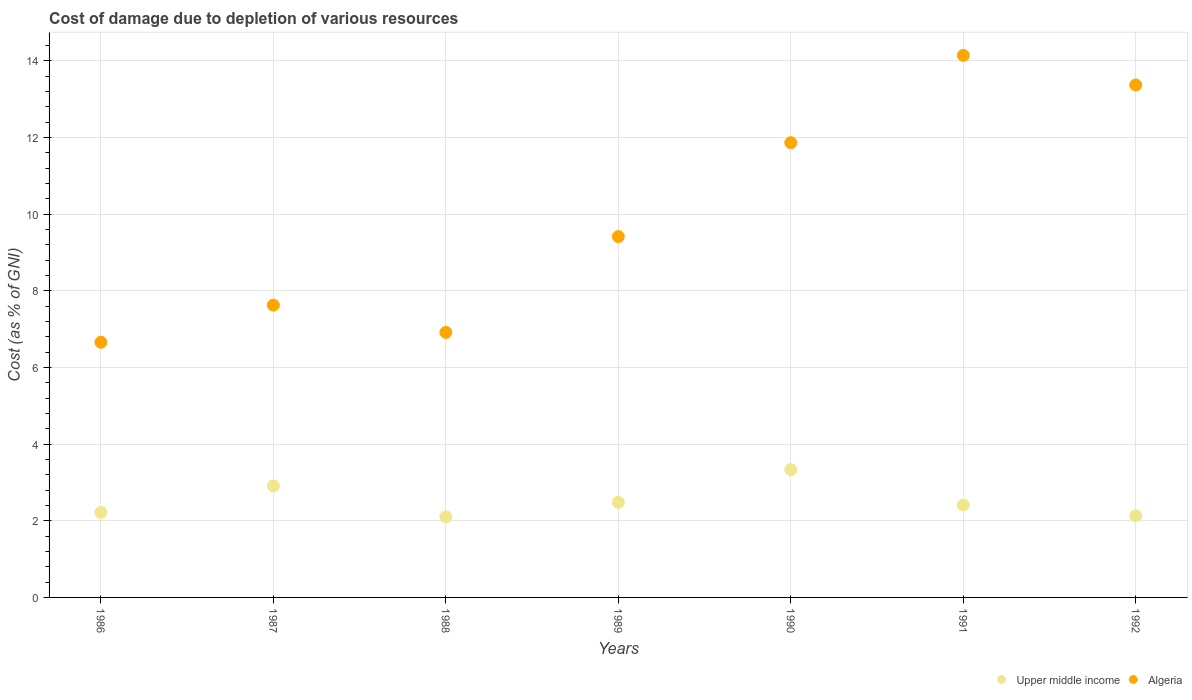What is the cost of damage caused due to the depletion of various resources in Upper middle income in 1989?
Ensure brevity in your answer.  2.48. Across all years, what is the maximum cost of damage caused due to the depletion of various resources in Algeria?
Keep it short and to the point. 14.15. Across all years, what is the minimum cost of damage caused due to the depletion of various resources in Algeria?
Provide a succinct answer. 6.66. In which year was the cost of damage caused due to the depletion of various resources in Algeria minimum?
Keep it short and to the point. 1986. What is the total cost of damage caused due to the depletion of various resources in Upper middle income in the graph?
Your answer should be very brief. 17.59. What is the difference between the cost of damage caused due to the depletion of various resources in Upper middle income in 1988 and that in 1991?
Your answer should be very brief. -0.31. What is the difference between the cost of damage caused due to the depletion of various resources in Upper middle income in 1990 and the cost of damage caused due to the depletion of various resources in Algeria in 1987?
Ensure brevity in your answer.  -4.29. What is the average cost of damage caused due to the depletion of various resources in Algeria per year?
Keep it short and to the point. 10. In the year 1987, what is the difference between the cost of damage caused due to the depletion of various resources in Algeria and cost of damage caused due to the depletion of various resources in Upper middle income?
Provide a succinct answer. 4.72. What is the ratio of the cost of damage caused due to the depletion of various resources in Algeria in 1989 to that in 1992?
Ensure brevity in your answer.  0.7. Is the cost of damage caused due to the depletion of various resources in Algeria in 1987 less than that in 1988?
Ensure brevity in your answer.  No. Is the difference between the cost of damage caused due to the depletion of various resources in Algeria in 1987 and 1990 greater than the difference between the cost of damage caused due to the depletion of various resources in Upper middle income in 1987 and 1990?
Offer a very short reply. No. What is the difference between the highest and the second highest cost of damage caused due to the depletion of various resources in Upper middle income?
Offer a very short reply. 0.42. What is the difference between the highest and the lowest cost of damage caused due to the depletion of various resources in Algeria?
Your answer should be very brief. 7.49. In how many years, is the cost of damage caused due to the depletion of various resources in Algeria greater than the average cost of damage caused due to the depletion of various resources in Algeria taken over all years?
Your response must be concise. 3. Is the cost of damage caused due to the depletion of various resources in Upper middle income strictly greater than the cost of damage caused due to the depletion of various resources in Algeria over the years?
Provide a succinct answer. No. Is the cost of damage caused due to the depletion of various resources in Upper middle income strictly less than the cost of damage caused due to the depletion of various resources in Algeria over the years?
Provide a succinct answer. Yes. How many years are there in the graph?
Your response must be concise. 7. Does the graph contain any zero values?
Ensure brevity in your answer.  No. Where does the legend appear in the graph?
Make the answer very short. Bottom right. How many legend labels are there?
Offer a very short reply. 2. How are the legend labels stacked?
Keep it short and to the point. Horizontal. What is the title of the graph?
Provide a short and direct response. Cost of damage due to depletion of various resources. Does "Kiribati" appear as one of the legend labels in the graph?
Offer a terse response. No. What is the label or title of the Y-axis?
Ensure brevity in your answer.  Cost (as % of GNI). What is the Cost (as % of GNI) in Upper middle income in 1986?
Provide a short and direct response. 2.22. What is the Cost (as % of GNI) in Algeria in 1986?
Provide a succinct answer. 6.66. What is the Cost (as % of GNI) of Upper middle income in 1987?
Keep it short and to the point. 2.91. What is the Cost (as % of GNI) in Algeria in 1987?
Provide a succinct answer. 7.63. What is the Cost (as % of GNI) of Upper middle income in 1988?
Give a very brief answer. 2.1. What is the Cost (as % of GNI) in Algeria in 1988?
Offer a very short reply. 6.92. What is the Cost (as % of GNI) of Upper middle income in 1989?
Provide a short and direct response. 2.48. What is the Cost (as % of GNI) in Algeria in 1989?
Your answer should be very brief. 9.42. What is the Cost (as % of GNI) of Upper middle income in 1990?
Provide a succinct answer. 3.33. What is the Cost (as % of GNI) of Algeria in 1990?
Give a very brief answer. 11.87. What is the Cost (as % of GNI) of Upper middle income in 1991?
Your answer should be compact. 2.41. What is the Cost (as % of GNI) in Algeria in 1991?
Provide a short and direct response. 14.15. What is the Cost (as % of GNI) in Upper middle income in 1992?
Provide a succinct answer. 2.13. What is the Cost (as % of GNI) in Algeria in 1992?
Make the answer very short. 13.37. Across all years, what is the maximum Cost (as % of GNI) in Upper middle income?
Offer a terse response. 3.33. Across all years, what is the maximum Cost (as % of GNI) of Algeria?
Your answer should be compact. 14.15. Across all years, what is the minimum Cost (as % of GNI) of Upper middle income?
Your answer should be very brief. 2.1. Across all years, what is the minimum Cost (as % of GNI) of Algeria?
Provide a succinct answer. 6.66. What is the total Cost (as % of GNI) of Upper middle income in the graph?
Your answer should be very brief. 17.59. What is the total Cost (as % of GNI) of Algeria in the graph?
Make the answer very short. 70.01. What is the difference between the Cost (as % of GNI) of Upper middle income in 1986 and that in 1987?
Offer a very short reply. -0.69. What is the difference between the Cost (as % of GNI) in Algeria in 1986 and that in 1987?
Your response must be concise. -0.97. What is the difference between the Cost (as % of GNI) in Upper middle income in 1986 and that in 1988?
Ensure brevity in your answer.  0.12. What is the difference between the Cost (as % of GNI) of Algeria in 1986 and that in 1988?
Ensure brevity in your answer.  -0.26. What is the difference between the Cost (as % of GNI) in Upper middle income in 1986 and that in 1989?
Provide a succinct answer. -0.26. What is the difference between the Cost (as % of GNI) in Algeria in 1986 and that in 1989?
Provide a succinct answer. -2.76. What is the difference between the Cost (as % of GNI) of Upper middle income in 1986 and that in 1990?
Ensure brevity in your answer.  -1.12. What is the difference between the Cost (as % of GNI) in Algeria in 1986 and that in 1990?
Your answer should be compact. -5.21. What is the difference between the Cost (as % of GNI) in Upper middle income in 1986 and that in 1991?
Your answer should be very brief. -0.19. What is the difference between the Cost (as % of GNI) in Algeria in 1986 and that in 1991?
Your response must be concise. -7.49. What is the difference between the Cost (as % of GNI) in Upper middle income in 1986 and that in 1992?
Offer a terse response. 0.09. What is the difference between the Cost (as % of GNI) in Algeria in 1986 and that in 1992?
Offer a very short reply. -6.71. What is the difference between the Cost (as % of GNI) of Upper middle income in 1987 and that in 1988?
Provide a short and direct response. 0.81. What is the difference between the Cost (as % of GNI) in Algeria in 1987 and that in 1988?
Your answer should be compact. 0.71. What is the difference between the Cost (as % of GNI) of Upper middle income in 1987 and that in 1989?
Provide a short and direct response. 0.43. What is the difference between the Cost (as % of GNI) in Algeria in 1987 and that in 1989?
Offer a terse response. -1.79. What is the difference between the Cost (as % of GNI) in Upper middle income in 1987 and that in 1990?
Offer a terse response. -0.42. What is the difference between the Cost (as % of GNI) of Algeria in 1987 and that in 1990?
Your answer should be compact. -4.24. What is the difference between the Cost (as % of GNI) of Upper middle income in 1987 and that in 1991?
Provide a succinct answer. 0.5. What is the difference between the Cost (as % of GNI) of Algeria in 1987 and that in 1991?
Ensure brevity in your answer.  -6.52. What is the difference between the Cost (as % of GNI) in Upper middle income in 1987 and that in 1992?
Keep it short and to the point. 0.78. What is the difference between the Cost (as % of GNI) in Algeria in 1987 and that in 1992?
Your answer should be very brief. -5.75. What is the difference between the Cost (as % of GNI) in Upper middle income in 1988 and that in 1989?
Ensure brevity in your answer.  -0.38. What is the difference between the Cost (as % of GNI) of Algeria in 1988 and that in 1989?
Offer a very short reply. -2.5. What is the difference between the Cost (as % of GNI) in Upper middle income in 1988 and that in 1990?
Give a very brief answer. -1.23. What is the difference between the Cost (as % of GNI) of Algeria in 1988 and that in 1990?
Keep it short and to the point. -4.95. What is the difference between the Cost (as % of GNI) of Upper middle income in 1988 and that in 1991?
Make the answer very short. -0.31. What is the difference between the Cost (as % of GNI) in Algeria in 1988 and that in 1991?
Offer a terse response. -7.23. What is the difference between the Cost (as % of GNI) in Upper middle income in 1988 and that in 1992?
Give a very brief answer. -0.03. What is the difference between the Cost (as % of GNI) of Algeria in 1988 and that in 1992?
Your answer should be very brief. -6.46. What is the difference between the Cost (as % of GNI) in Upper middle income in 1989 and that in 1990?
Ensure brevity in your answer.  -0.85. What is the difference between the Cost (as % of GNI) in Algeria in 1989 and that in 1990?
Offer a very short reply. -2.45. What is the difference between the Cost (as % of GNI) in Upper middle income in 1989 and that in 1991?
Offer a terse response. 0.07. What is the difference between the Cost (as % of GNI) in Algeria in 1989 and that in 1991?
Ensure brevity in your answer.  -4.73. What is the difference between the Cost (as % of GNI) in Upper middle income in 1989 and that in 1992?
Keep it short and to the point. 0.35. What is the difference between the Cost (as % of GNI) in Algeria in 1989 and that in 1992?
Offer a very short reply. -3.96. What is the difference between the Cost (as % of GNI) in Upper middle income in 1990 and that in 1991?
Ensure brevity in your answer.  0.92. What is the difference between the Cost (as % of GNI) of Algeria in 1990 and that in 1991?
Your response must be concise. -2.28. What is the difference between the Cost (as % of GNI) of Upper middle income in 1990 and that in 1992?
Offer a terse response. 1.2. What is the difference between the Cost (as % of GNI) of Algeria in 1990 and that in 1992?
Offer a terse response. -1.51. What is the difference between the Cost (as % of GNI) in Upper middle income in 1991 and that in 1992?
Offer a terse response. 0.28. What is the difference between the Cost (as % of GNI) of Algeria in 1991 and that in 1992?
Your response must be concise. 0.77. What is the difference between the Cost (as % of GNI) in Upper middle income in 1986 and the Cost (as % of GNI) in Algeria in 1987?
Keep it short and to the point. -5.41. What is the difference between the Cost (as % of GNI) of Upper middle income in 1986 and the Cost (as % of GNI) of Algeria in 1988?
Your answer should be very brief. -4.7. What is the difference between the Cost (as % of GNI) of Upper middle income in 1986 and the Cost (as % of GNI) of Algeria in 1989?
Give a very brief answer. -7.2. What is the difference between the Cost (as % of GNI) of Upper middle income in 1986 and the Cost (as % of GNI) of Algeria in 1990?
Provide a succinct answer. -9.65. What is the difference between the Cost (as % of GNI) of Upper middle income in 1986 and the Cost (as % of GNI) of Algeria in 1991?
Offer a terse response. -11.93. What is the difference between the Cost (as % of GNI) of Upper middle income in 1986 and the Cost (as % of GNI) of Algeria in 1992?
Provide a short and direct response. -11.16. What is the difference between the Cost (as % of GNI) in Upper middle income in 1987 and the Cost (as % of GNI) in Algeria in 1988?
Give a very brief answer. -4.01. What is the difference between the Cost (as % of GNI) of Upper middle income in 1987 and the Cost (as % of GNI) of Algeria in 1989?
Your response must be concise. -6.51. What is the difference between the Cost (as % of GNI) in Upper middle income in 1987 and the Cost (as % of GNI) in Algeria in 1990?
Provide a short and direct response. -8.96. What is the difference between the Cost (as % of GNI) in Upper middle income in 1987 and the Cost (as % of GNI) in Algeria in 1991?
Make the answer very short. -11.24. What is the difference between the Cost (as % of GNI) of Upper middle income in 1987 and the Cost (as % of GNI) of Algeria in 1992?
Your response must be concise. -10.46. What is the difference between the Cost (as % of GNI) in Upper middle income in 1988 and the Cost (as % of GNI) in Algeria in 1989?
Provide a short and direct response. -7.31. What is the difference between the Cost (as % of GNI) of Upper middle income in 1988 and the Cost (as % of GNI) of Algeria in 1990?
Your response must be concise. -9.77. What is the difference between the Cost (as % of GNI) of Upper middle income in 1988 and the Cost (as % of GNI) of Algeria in 1991?
Your answer should be compact. -12.04. What is the difference between the Cost (as % of GNI) in Upper middle income in 1988 and the Cost (as % of GNI) in Algeria in 1992?
Make the answer very short. -11.27. What is the difference between the Cost (as % of GNI) in Upper middle income in 1989 and the Cost (as % of GNI) in Algeria in 1990?
Provide a short and direct response. -9.39. What is the difference between the Cost (as % of GNI) of Upper middle income in 1989 and the Cost (as % of GNI) of Algeria in 1991?
Your answer should be very brief. -11.67. What is the difference between the Cost (as % of GNI) of Upper middle income in 1989 and the Cost (as % of GNI) of Algeria in 1992?
Your answer should be compact. -10.89. What is the difference between the Cost (as % of GNI) of Upper middle income in 1990 and the Cost (as % of GNI) of Algeria in 1991?
Your answer should be very brief. -10.81. What is the difference between the Cost (as % of GNI) in Upper middle income in 1990 and the Cost (as % of GNI) in Algeria in 1992?
Offer a very short reply. -10.04. What is the difference between the Cost (as % of GNI) in Upper middle income in 1991 and the Cost (as % of GNI) in Algeria in 1992?
Your response must be concise. -10.96. What is the average Cost (as % of GNI) of Upper middle income per year?
Offer a terse response. 2.51. What is the average Cost (as % of GNI) in Algeria per year?
Provide a short and direct response. 10. In the year 1986, what is the difference between the Cost (as % of GNI) of Upper middle income and Cost (as % of GNI) of Algeria?
Provide a succinct answer. -4.44. In the year 1987, what is the difference between the Cost (as % of GNI) in Upper middle income and Cost (as % of GNI) in Algeria?
Your answer should be compact. -4.72. In the year 1988, what is the difference between the Cost (as % of GNI) in Upper middle income and Cost (as % of GNI) in Algeria?
Provide a short and direct response. -4.81. In the year 1989, what is the difference between the Cost (as % of GNI) of Upper middle income and Cost (as % of GNI) of Algeria?
Provide a succinct answer. -6.94. In the year 1990, what is the difference between the Cost (as % of GNI) in Upper middle income and Cost (as % of GNI) in Algeria?
Your response must be concise. -8.53. In the year 1991, what is the difference between the Cost (as % of GNI) in Upper middle income and Cost (as % of GNI) in Algeria?
Your response must be concise. -11.73. In the year 1992, what is the difference between the Cost (as % of GNI) in Upper middle income and Cost (as % of GNI) in Algeria?
Provide a short and direct response. -11.24. What is the ratio of the Cost (as % of GNI) in Upper middle income in 1986 to that in 1987?
Ensure brevity in your answer.  0.76. What is the ratio of the Cost (as % of GNI) in Algeria in 1986 to that in 1987?
Keep it short and to the point. 0.87. What is the ratio of the Cost (as % of GNI) of Upper middle income in 1986 to that in 1988?
Ensure brevity in your answer.  1.06. What is the ratio of the Cost (as % of GNI) of Algeria in 1986 to that in 1988?
Your response must be concise. 0.96. What is the ratio of the Cost (as % of GNI) in Upper middle income in 1986 to that in 1989?
Ensure brevity in your answer.  0.89. What is the ratio of the Cost (as % of GNI) in Algeria in 1986 to that in 1989?
Provide a succinct answer. 0.71. What is the ratio of the Cost (as % of GNI) of Upper middle income in 1986 to that in 1990?
Offer a terse response. 0.67. What is the ratio of the Cost (as % of GNI) of Algeria in 1986 to that in 1990?
Offer a terse response. 0.56. What is the ratio of the Cost (as % of GNI) of Upper middle income in 1986 to that in 1991?
Offer a very short reply. 0.92. What is the ratio of the Cost (as % of GNI) of Algeria in 1986 to that in 1991?
Ensure brevity in your answer.  0.47. What is the ratio of the Cost (as % of GNI) of Upper middle income in 1986 to that in 1992?
Keep it short and to the point. 1.04. What is the ratio of the Cost (as % of GNI) of Algeria in 1986 to that in 1992?
Provide a succinct answer. 0.5. What is the ratio of the Cost (as % of GNI) of Upper middle income in 1987 to that in 1988?
Your answer should be very brief. 1.38. What is the ratio of the Cost (as % of GNI) of Algeria in 1987 to that in 1988?
Offer a terse response. 1.1. What is the ratio of the Cost (as % of GNI) of Upper middle income in 1987 to that in 1989?
Make the answer very short. 1.17. What is the ratio of the Cost (as % of GNI) of Algeria in 1987 to that in 1989?
Your answer should be compact. 0.81. What is the ratio of the Cost (as % of GNI) in Upper middle income in 1987 to that in 1990?
Keep it short and to the point. 0.87. What is the ratio of the Cost (as % of GNI) in Algeria in 1987 to that in 1990?
Your answer should be compact. 0.64. What is the ratio of the Cost (as % of GNI) of Upper middle income in 1987 to that in 1991?
Ensure brevity in your answer.  1.21. What is the ratio of the Cost (as % of GNI) of Algeria in 1987 to that in 1991?
Your response must be concise. 0.54. What is the ratio of the Cost (as % of GNI) of Upper middle income in 1987 to that in 1992?
Your response must be concise. 1.36. What is the ratio of the Cost (as % of GNI) in Algeria in 1987 to that in 1992?
Provide a short and direct response. 0.57. What is the ratio of the Cost (as % of GNI) in Upper middle income in 1988 to that in 1989?
Your answer should be very brief. 0.85. What is the ratio of the Cost (as % of GNI) of Algeria in 1988 to that in 1989?
Make the answer very short. 0.73. What is the ratio of the Cost (as % of GNI) in Upper middle income in 1988 to that in 1990?
Your answer should be very brief. 0.63. What is the ratio of the Cost (as % of GNI) of Algeria in 1988 to that in 1990?
Provide a short and direct response. 0.58. What is the ratio of the Cost (as % of GNI) in Upper middle income in 1988 to that in 1991?
Offer a very short reply. 0.87. What is the ratio of the Cost (as % of GNI) of Algeria in 1988 to that in 1991?
Offer a very short reply. 0.49. What is the ratio of the Cost (as % of GNI) in Upper middle income in 1988 to that in 1992?
Keep it short and to the point. 0.99. What is the ratio of the Cost (as % of GNI) of Algeria in 1988 to that in 1992?
Your answer should be compact. 0.52. What is the ratio of the Cost (as % of GNI) of Upper middle income in 1989 to that in 1990?
Keep it short and to the point. 0.74. What is the ratio of the Cost (as % of GNI) of Algeria in 1989 to that in 1990?
Give a very brief answer. 0.79. What is the ratio of the Cost (as % of GNI) in Upper middle income in 1989 to that in 1991?
Provide a succinct answer. 1.03. What is the ratio of the Cost (as % of GNI) of Algeria in 1989 to that in 1991?
Offer a very short reply. 0.67. What is the ratio of the Cost (as % of GNI) of Upper middle income in 1989 to that in 1992?
Provide a short and direct response. 1.16. What is the ratio of the Cost (as % of GNI) of Algeria in 1989 to that in 1992?
Ensure brevity in your answer.  0.7. What is the ratio of the Cost (as % of GNI) in Upper middle income in 1990 to that in 1991?
Give a very brief answer. 1.38. What is the ratio of the Cost (as % of GNI) of Algeria in 1990 to that in 1991?
Your answer should be very brief. 0.84. What is the ratio of the Cost (as % of GNI) in Upper middle income in 1990 to that in 1992?
Your answer should be compact. 1.56. What is the ratio of the Cost (as % of GNI) in Algeria in 1990 to that in 1992?
Offer a very short reply. 0.89. What is the ratio of the Cost (as % of GNI) of Upper middle income in 1991 to that in 1992?
Offer a very short reply. 1.13. What is the ratio of the Cost (as % of GNI) of Algeria in 1991 to that in 1992?
Your answer should be compact. 1.06. What is the difference between the highest and the second highest Cost (as % of GNI) in Upper middle income?
Offer a very short reply. 0.42. What is the difference between the highest and the second highest Cost (as % of GNI) of Algeria?
Give a very brief answer. 0.77. What is the difference between the highest and the lowest Cost (as % of GNI) of Upper middle income?
Give a very brief answer. 1.23. What is the difference between the highest and the lowest Cost (as % of GNI) in Algeria?
Provide a short and direct response. 7.49. 